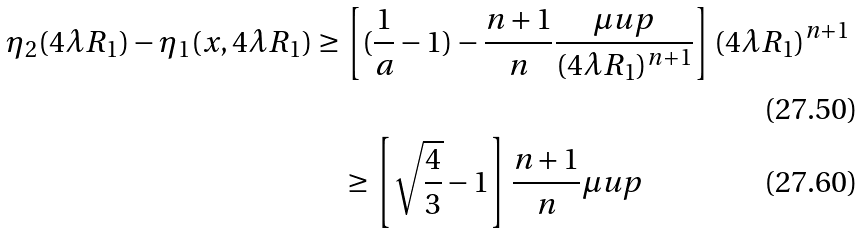Convert formula to latex. <formula><loc_0><loc_0><loc_500><loc_500>\eta _ { 2 } ( 4 \lambda R _ { 1 } ) - \eta _ { 1 } ( x , 4 \lambda R _ { 1 } ) & \geq \left [ ( \frac { 1 } { a } - 1 ) - \frac { n + 1 } { n } \frac { \mu u p } { ( 4 \lambda R _ { 1 } ) ^ { n + 1 } } \right ] ( 4 \lambda R _ { 1 } ) ^ { n + 1 } \\ & \quad \geq \left [ \sqrt { \frac { 4 } { 3 } } - 1 \right ] \frac { n + 1 } { n } \mu u p</formula> 